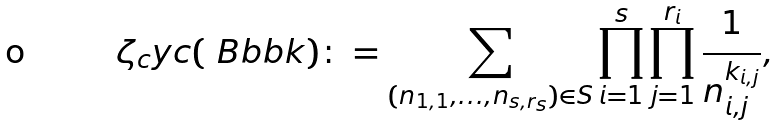Convert formula to latex. <formula><loc_0><loc_0><loc_500><loc_500>\zeta _ { c } y c ( \ B b b k ) \colon = \sum _ { ( n _ { 1 , 1 } , \dots , n _ { s , r _ { s } } ) \in S } \prod _ { i = 1 } ^ { s } \prod _ { j = 1 } ^ { r _ { i } } \frac { 1 } { n _ { i , j } ^ { k _ { i , j } } } ,</formula> 